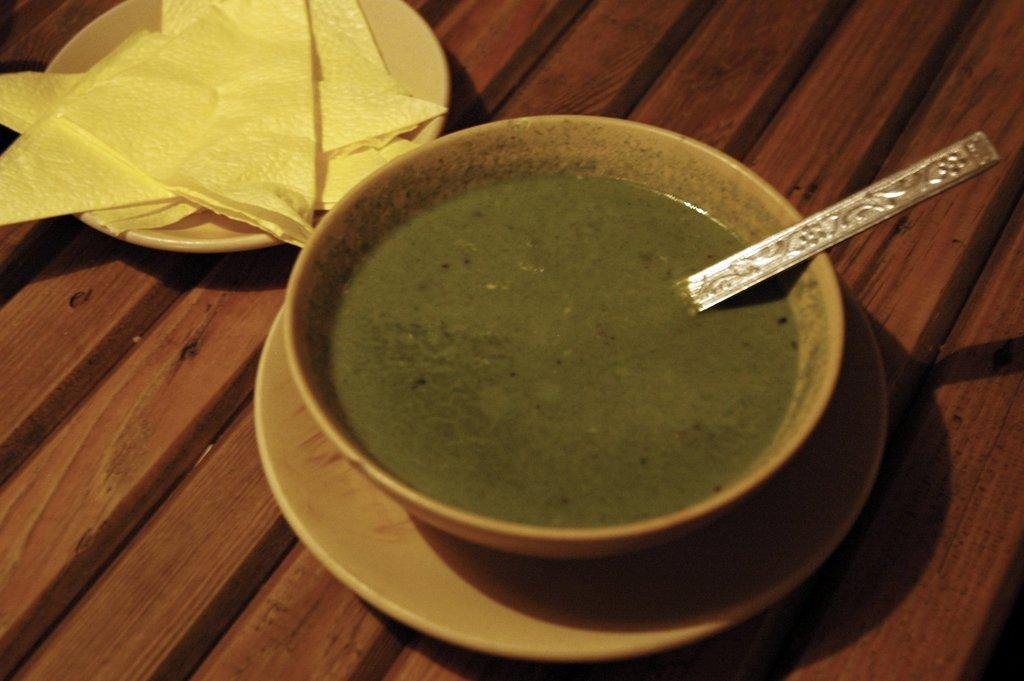What is in the bowl that is visible in the image? There is a bowl with a food item in the image. What utensil is present on the surface in the image? There is a spoon on the surface in the image. What else can be seen on the surface in the image? There is a plate with tissues on the surface in the image. What type of game is being played in the image? There is no game being played in the image; it only features a bowl with a food item, a spoon, and a plate with tissues. 